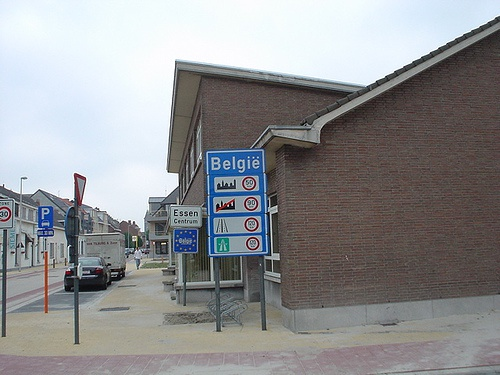Describe the objects in this image and their specific colors. I can see truck in lavender, gray, and black tones, car in lavender, black, gray, and darkgray tones, car in lavender, black, gray, and darkgray tones, people in lavender, darkgray, gray, and lightgray tones, and car in lavender, gray, darkgray, and black tones in this image. 